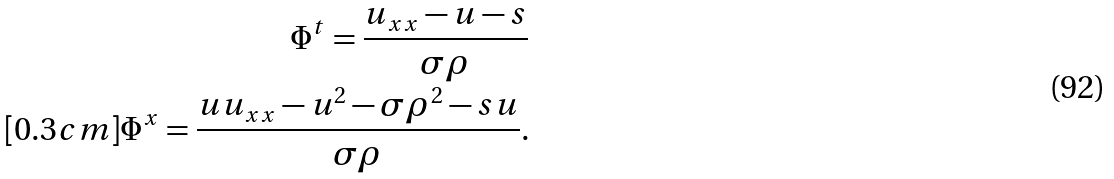Convert formula to latex. <formula><loc_0><loc_0><loc_500><loc_500>\Phi ^ { t } = \frac { u _ { x x } - u - s } { \sigma \rho } \\ [ 0 . 3 c m ] \Phi ^ { x } = \frac { u u _ { x x } - u ^ { 2 } - \sigma \rho ^ { 2 } - s u } { \sigma \rho } .</formula> 